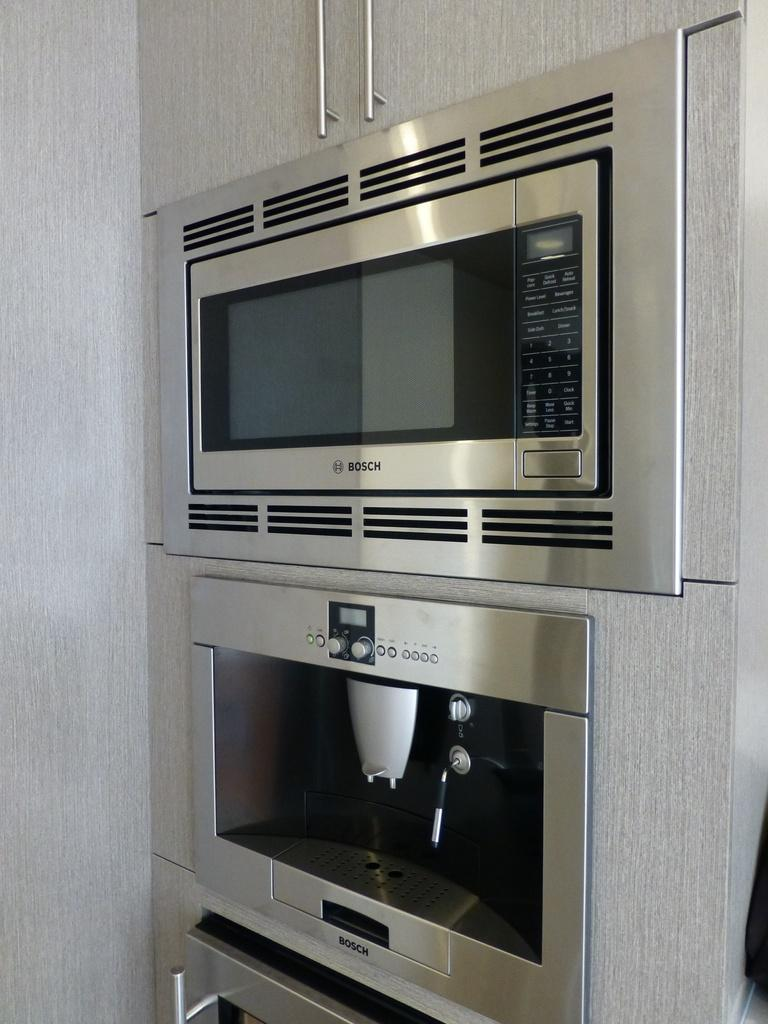<image>
Summarize the visual content of the image. A microwave from the company Bosch on top of another kitchen device 